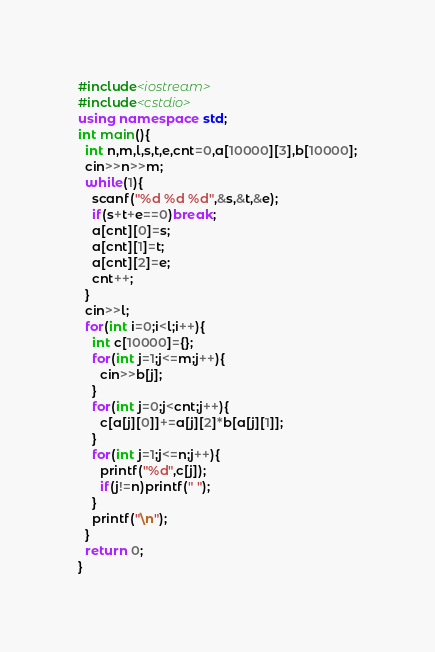<code> <loc_0><loc_0><loc_500><loc_500><_C++_>#include<iostream>
#include<cstdio>
using namespace std;
int main(){
  int n,m,l,s,t,e,cnt=0,a[10000][3],b[10000];
  cin>>n>>m;
  while(1){
    scanf("%d %d %d",&s,&t,&e);
    if(s+t+e==0)break;
    a[cnt][0]=s;
    a[cnt][1]=t;
    a[cnt][2]=e;
    cnt++;
  }
  cin>>l;
  for(int i=0;i<l;i++){
    int c[10000]={};
    for(int j=1;j<=m;j++){
      cin>>b[j];
    }
    for(int j=0;j<cnt;j++){
      c[a[j][0]]+=a[j][2]*b[a[j][1]];
    }
    for(int j=1;j<=n;j++){
      printf("%d",c[j]);
      if(j!=n)printf(" ");
    }
    printf("\n");
  }
  return 0;
}</code> 